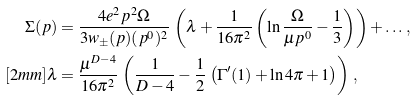<formula> <loc_0><loc_0><loc_500><loc_500>\Sigma ( p ) & = \frac { 4 e ^ { 2 } { p } ^ { 2 } \Omega } { 3 w _ { \pm } ( { p } ) ( p ^ { 0 } ) ^ { 2 } } \, \left ( \lambda + \frac { 1 } { 1 6 \pi ^ { 2 } } \left ( \ln \frac { \Omega } { \mu p ^ { 0 } } - \frac { 1 } { 3 } \right ) \right ) + \dots \, , \\ [ 2 m m ] \lambda & = \frac { \mu ^ { D - 4 } } { 1 6 \pi ^ { 2 } } \, \left ( \frac { 1 } { D - 4 } - \frac { 1 } { 2 } \, \left ( \Gamma ^ { \prime } ( 1 ) + \ln 4 \pi + 1 \right ) \right ) \, ,</formula> 